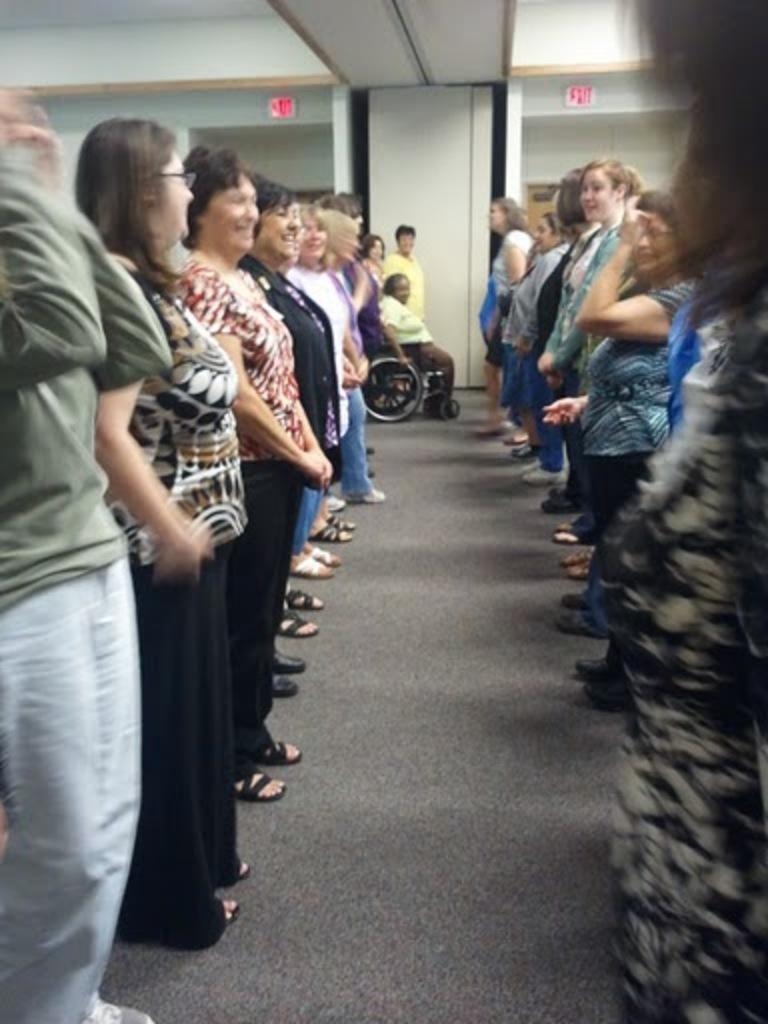What is happening in the room in the image? There are people standing in the room. Can you describe the person in the background? There is a person sitting on a wheelchair in the background. What is attached to the wall in the image? There is a board with text attached to the wall. What type of cheese is being served on the route mentioned on the board? There is no cheese or route mentioned in the image; the board only has text attached to it. 